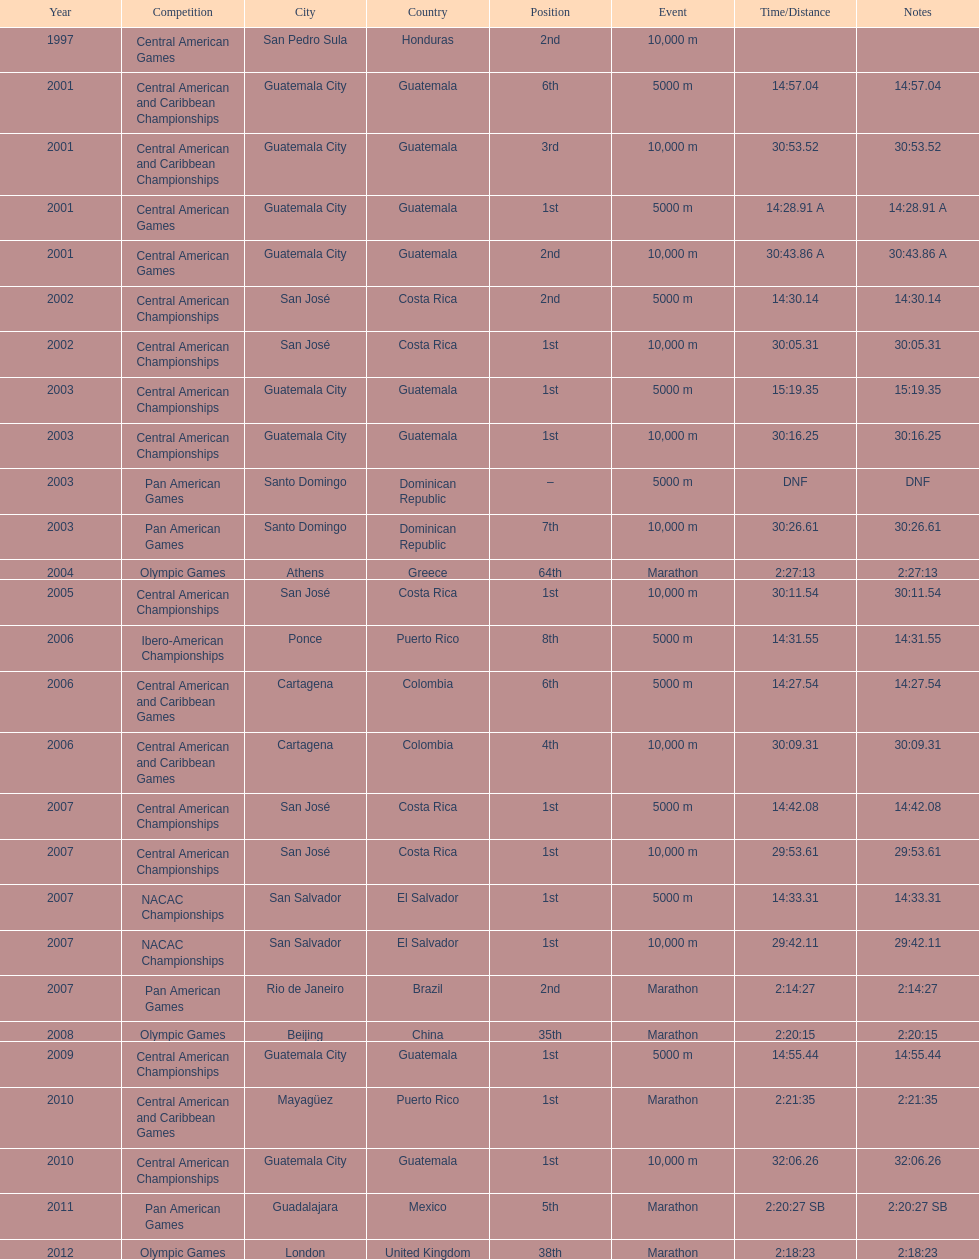What competition did this competitor compete at after participating in the central american games in 2001? Central American Championships. 